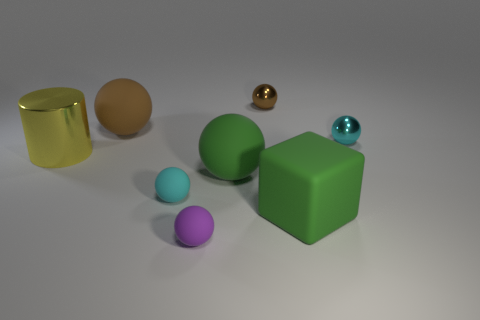What number of rubber objects are brown things or large green cubes?
Your response must be concise. 2. Do the block and the tiny purple object have the same material?
Your answer should be very brief. Yes. The small cyan object that is to the left of the tiny cyan shiny object has what shape?
Your answer should be compact. Sphere. There is a cyan sphere that is left of the small brown metal sphere; is there a yellow shiny cylinder that is in front of it?
Provide a short and direct response. No. Is there a cyan rubber sphere that has the same size as the metal cylinder?
Offer a very short reply. No. Is the color of the small ball that is in front of the green cube the same as the block?
Make the answer very short. No. How big is the cyan shiny sphere?
Your answer should be compact. Small. There is a cyan ball that is right of the big cube that is to the right of the big cylinder; what is its size?
Offer a very short reply. Small. How many metal spheres are the same color as the metallic cylinder?
Your response must be concise. 0. What number of big balls are there?
Give a very brief answer. 2. 